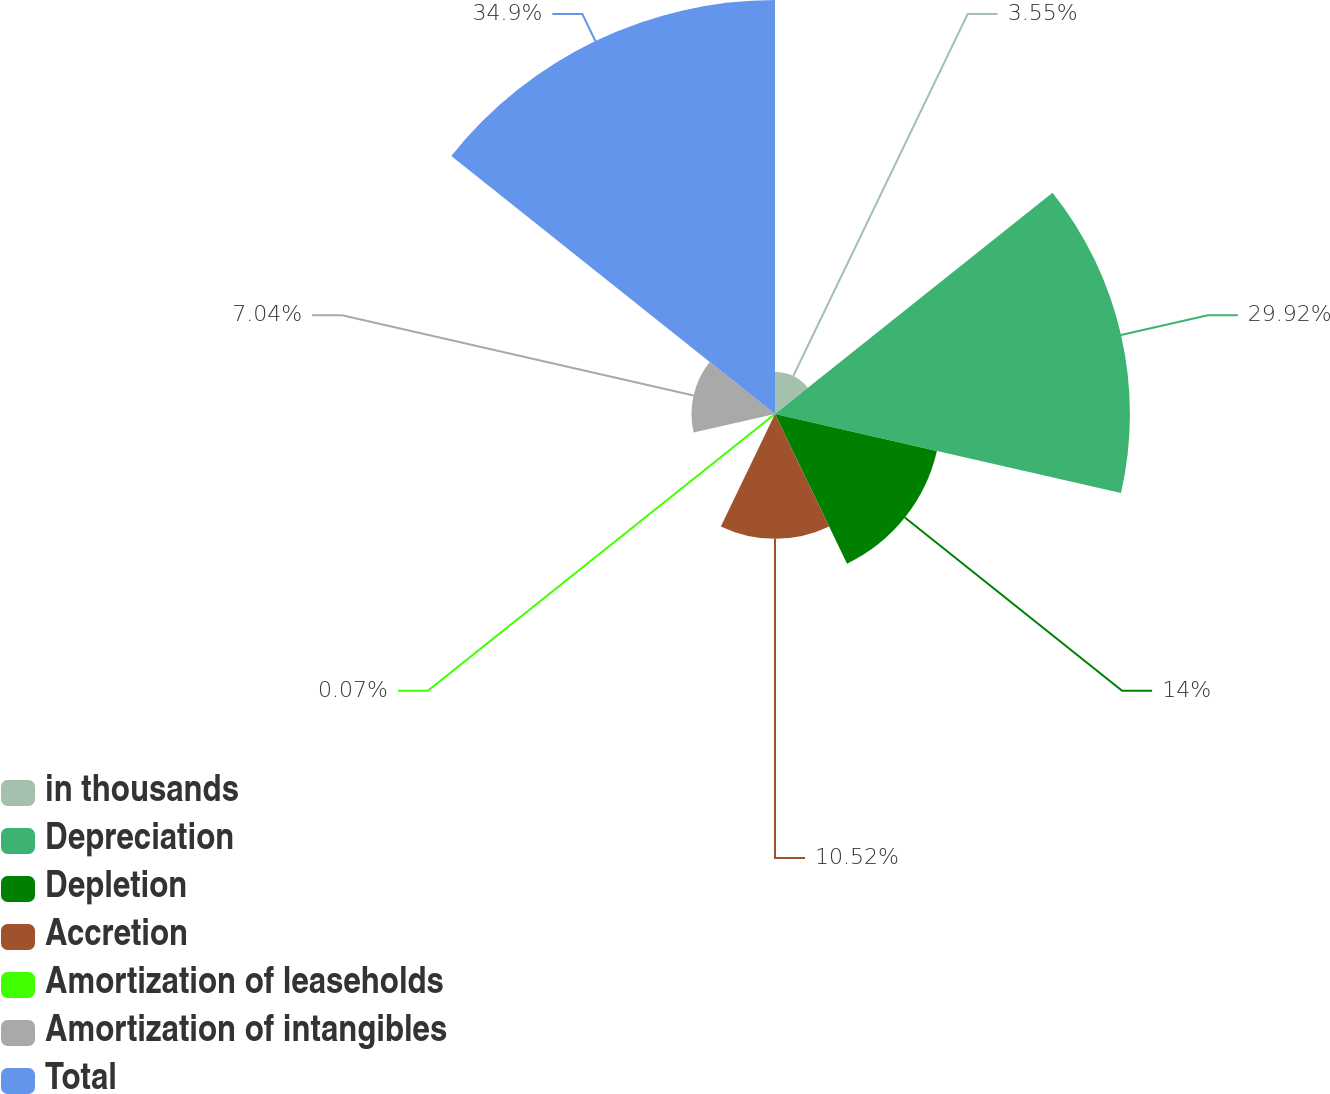<chart> <loc_0><loc_0><loc_500><loc_500><pie_chart><fcel>in thousands<fcel>Depreciation<fcel>Depletion<fcel>Accretion<fcel>Amortization of leaseholds<fcel>Amortization of intangibles<fcel>Total<nl><fcel>3.55%<fcel>29.92%<fcel>14.0%<fcel>10.52%<fcel>0.07%<fcel>7.04%<fcel>34.9%<nl></chart> 